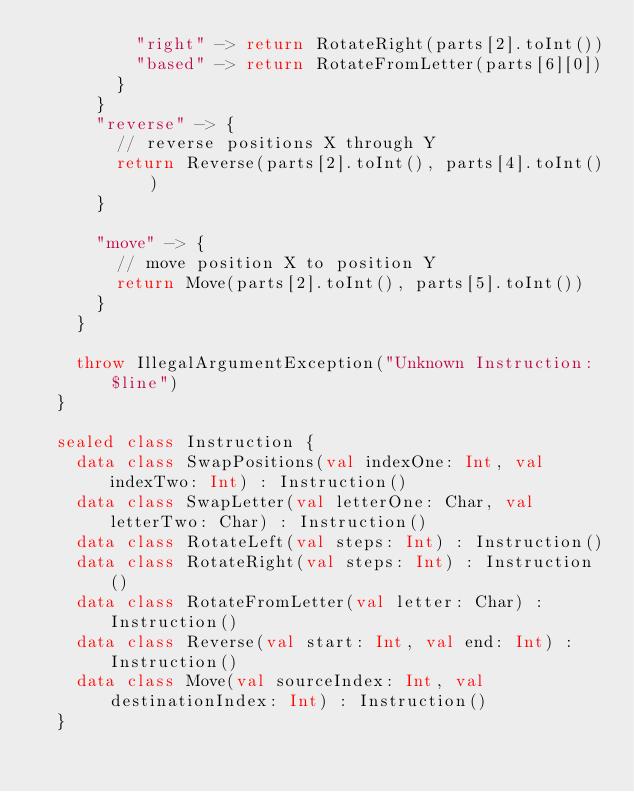<code> <loc_0><loc_0><loc_500><loc_500><_Kotlin_>          "right" -> return RotateRight(parts[2].toInt())
          "based" -> return RotateFromLetter(parts[6][0])
        }
      }
      "reverse" -> {
        // reverse positions X through Y
        return Reverse(parts[2].toInt(), parts[4].toInt())
      }

      "move" -> {
        // move position X to position Y
        return Move(parts[2].toInt(), parts[5].toInt())
      }
    }

    throw IllegalArgumentException("Unknown Instruction: $line")
  }

  sealed class Instruction {
    data class SwapPositions(val indexOne: Int, val indexTwo: Int) : Instruction()
    data class SwapLetter(val letterOne: Char, val letterTwo: Char) : Instruction()
    data class RotateLeft(val steps: Int) : Instruction()
    data class RotateRight(val steps: Int) : Instruction()
    data class RotateFromLetter(val letter: Char) : Instruction()
    data class Reverse(val start: Int, val end: Int) : Instruction()
    data class Move(val sourceIndex: Int, val destinationIndex: Int) : Instruction()
  }
</code> 